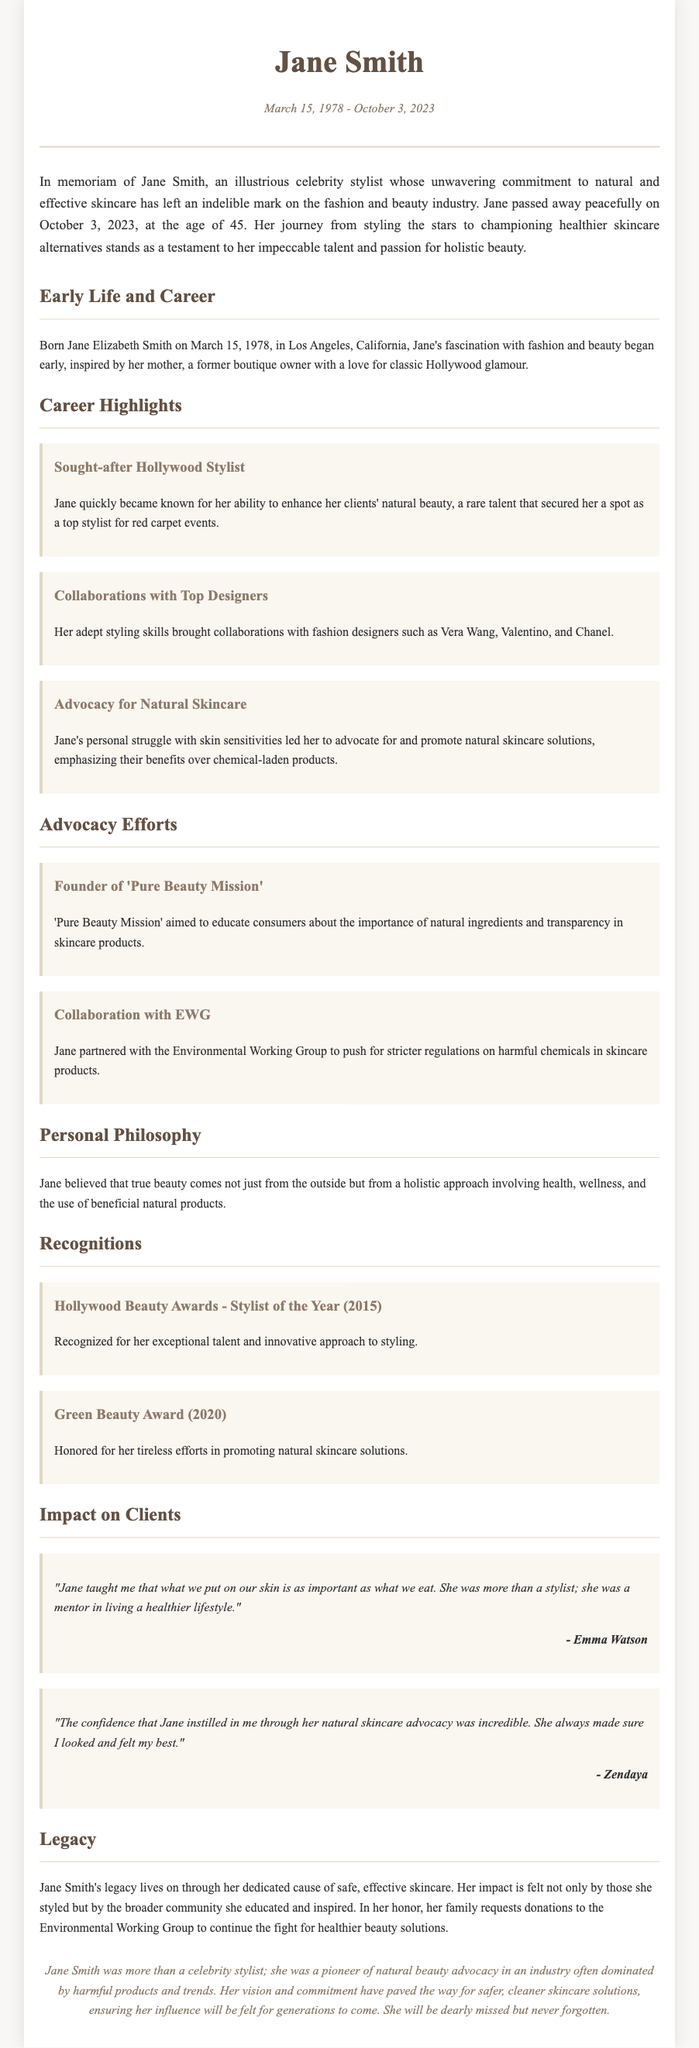what is the full name of the stylist? The document mentions her full name as Jane Elizabeth Smith.
Answer: Jane Elizabeth Smith when was Jane Smith born? The document states her birth date as March 15, 1978.
Answer: March 15, 1978 how old was Jane Smith at the time of her passing? The document indicates she passed away at the age of 45.
Answer: 45 what was the name of the advocacy group founded by Jane Smith? The document refers to the advocacy group as 'Pure Beauty Mission'.
Answer: Pure Beauty Mission which award did she win in 2015? The document lists the award as Hollywood Beauty Awards - Stylist of the Year.
Answer: Hollywood Beauty Awards - Stylist of the Year what personal struggle motivated Jane's skincare advocacy? The document mentions her struggle with skin sensitivities as the motivation for her advocacy.
Answer: skin sensitivities which prominent actress mentioned Jane as a mentor? The document quotes Emma Watson acknowledging Jane's mentoring.
Answer: Emma Watson what was Jane Smith’s philosophy on beauty? The document explains her philosophy as having a holistic approach involving health and wellness.
Answer: holistic approach involving health and wellness what does the family request in Jane's honor? The document states that her family requests donations to the Environmental Working Group.
Answer: donations to the Environmental Working Group 